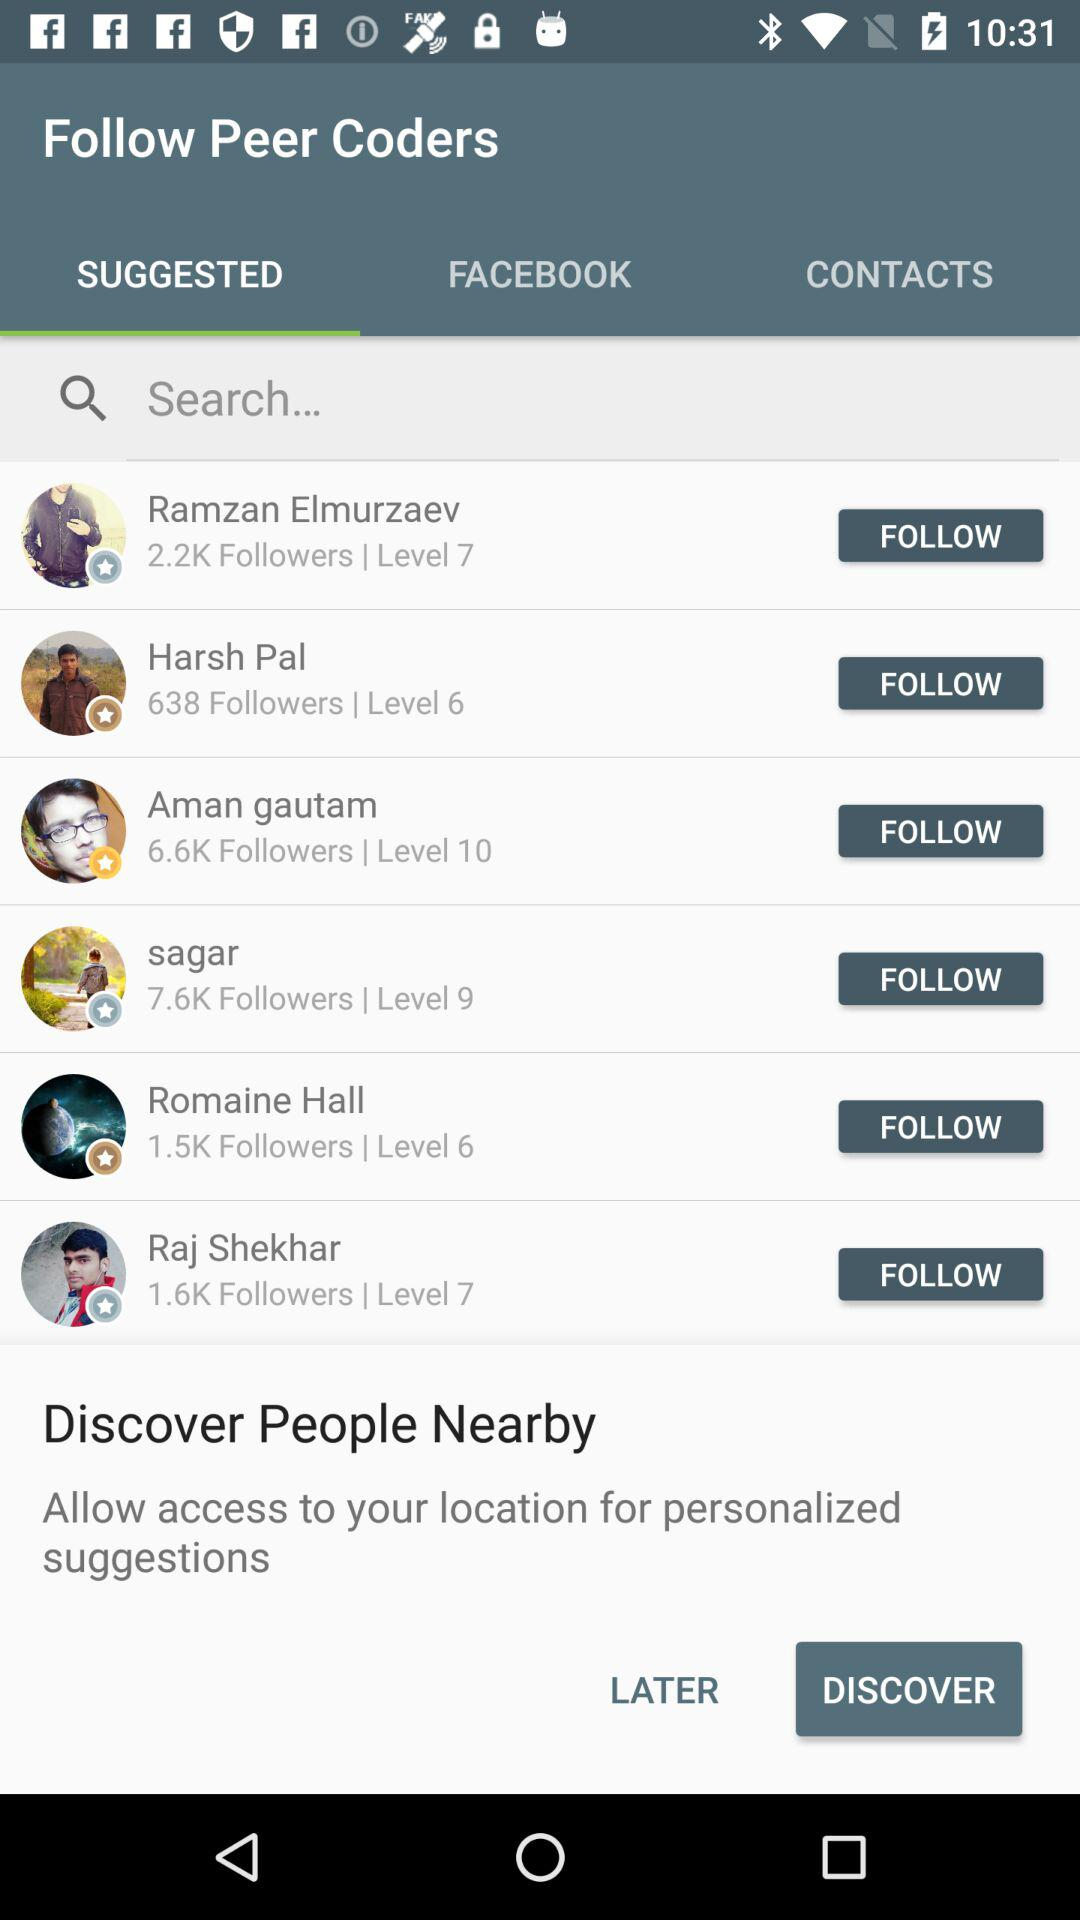How many people are following Sagar? There are 7.6K people who are following Sagar. 